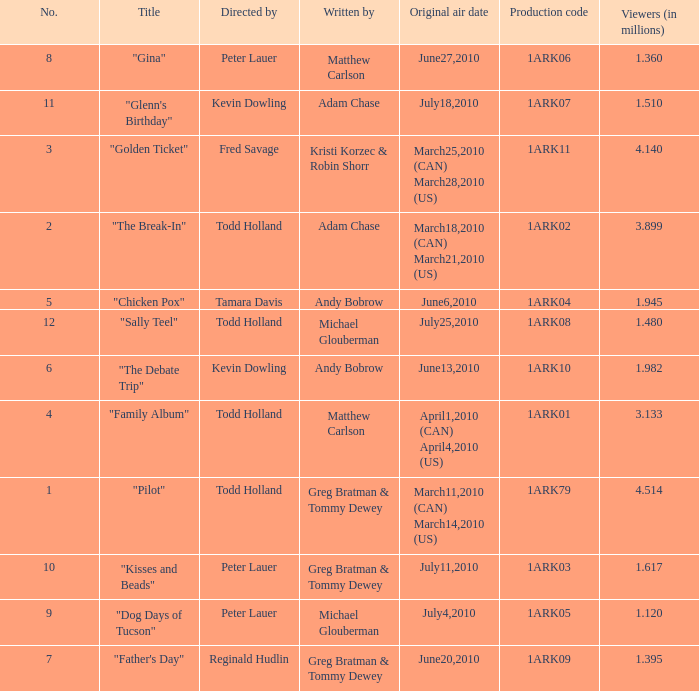List all directors from episodes with viewership of 1.945 million. Tamara Davis. 